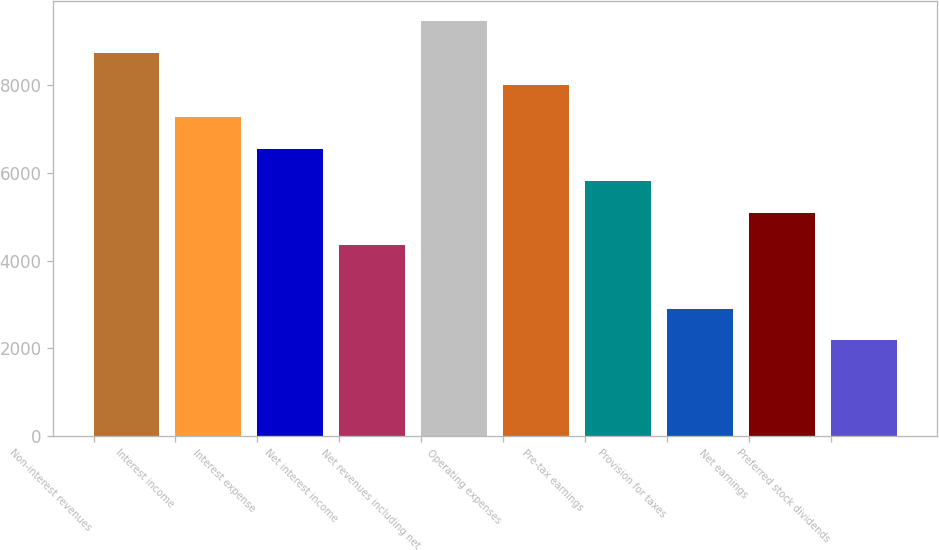Convert chart to OTSL. <chart><loc_0><loc_0><loc_500><loc_500><bar_chart><fcel>Non-interest revenues<fcel>Interest income<fcel>Interest expense<fcel>Net interest income<fcel>Net revenues including net<fcel>Operating expenses<fcel>Pre-tax earnings<fcel>Provision for taxes<fcel>Net earnings<fcel>Preferred stock dividends<nl><fcel>8727.5<fcel>7273.03<fcel>6545.8<fcel>4364.08<fcel>9454.74<fcel>8000.26<fcel>5818.56<fcel>2909.6<fcel>5091.32<fcel>2182.36<nl></chart> 